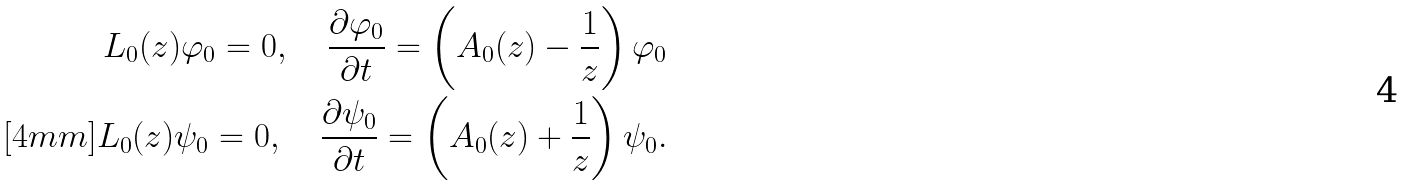Convert formula to latex. <formula><loc_0><loc_0><loc_500><loc_500>L _ { 0 } ( z ) \varphi _ { 0 } = 0 , \quad \frac { \partial \varphi _ { 0 } } { \partial t } = \left ( A _ { 0 } ( z ) - \frac { 1 } { z } \right ) \varphi _ { 0 } \\ [ 4 m m ] L _ { 0 } ( z ) \psi _ { 0 } = 0 , \quad \frac { \partial \psi _ { 0 } } { \partial t } = \left ( A _ { 0 } ( z ) + \frac { 1 } { z } \right ) \psi _ { 0 } .</formula> 